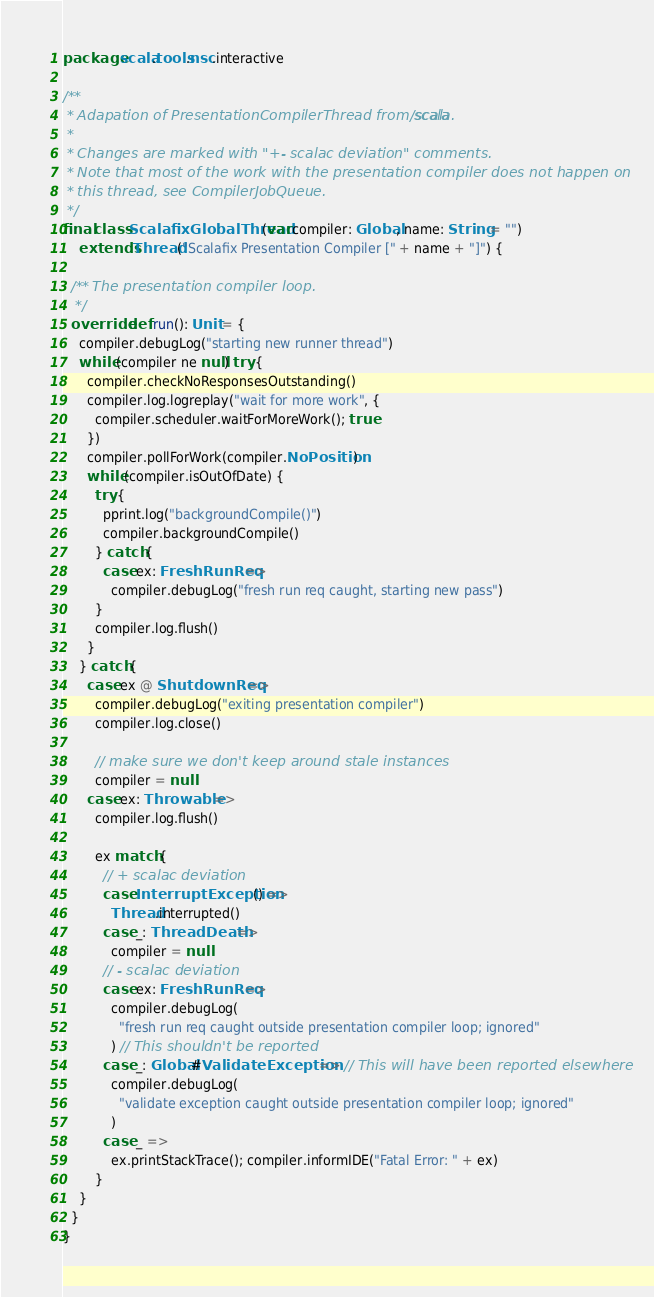Convert code to text. <code><loc_0><loc_0><loc_500><loc_500><_Scala_>package scala.tools.nsc.interactive

/**
 * Adapation of PresentationCompilerThread from scala/scala.
 *
 * Changes are marked with "+- scalac deviation" comments.
 * Note that most of the work with the presentation compiler does not happen on
 * this thread, see CompilerJobQueue.
 */
final class ScalafixGlobalThread(var compiler: Global, name: String = "")
    extends Thread("Scalafix Presentation Compiler [" + name + "]") {

  /** The presentation compiler loop.
   */
  override def run(): Unit = {
    compiler.debugLog("starting new runner thread")
    while (compiler ne null) try {
      compiler.checkNoResponsesOutstanding()
      compiler.log.logreplay("wait for more work", {
        compiler.scheduler.waitForMoreWork(); true
      })
      compiler.pollForWork(compiler.NoPosition)
      while (compiler.isOutOfDate) {
        try {
          pprint.log("backgroundCompile()")
          compiler.backgroundCompile()
        } catch {
          case ex: FreshRunReq =>
            compiler.debugLog("fresh run req caught, starting new pass")
        }
        compiler.log.flush()
      }
    } catch {
      case ex @ ShutdownReq =>
        compiler.debugLog("exiting presentation compiler")
        compiler.log.close()

        // make sure we don't keep around stale instances
        compiler = null
      case ex: Throwable =>
        compiler.log.flush()

        ex match {
          // + scalac deviation
          case InterruptException() =>
            Thread.interrupted()
          case _: ThreadDeath =>
            compiler = null
          // - scalac deviation
          case ex: FreshRunReq =>
            compiler.debugLog(
              "fresh run req caught outside presentation compiler loop; ignored"
            ) // This shouldn't be reported
          case _: Global#ValidateException => // This will have been reported elsewhere
            compiler.debugLog(
              "validate exception caught outside presentation compiler loop; ignored"
            )
          case _ =>
            ex.printStackTrace(); compiler.informIDE("Fatal Error: " + ex)
        }
    }
  }
}
</code> 